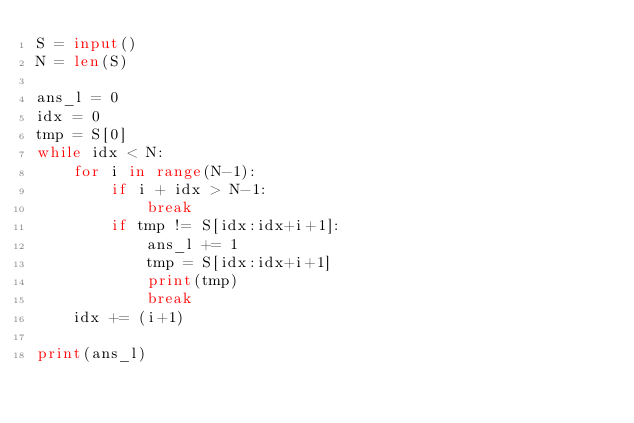<code> <loc_0><loc_0><loc_500><loc_500><_Python_>S = input()
N = len(S)

ans_l = 0
idx = 0
tmp = S[0]
while idx < N:
    for i in range(N-1):
        if i + idx > N-1:
            break
        if tmp != S[idx:idx+i+1]:
            ans_l += 1
            tmp = S[idx:idx+i+1]
            print(tmp)
            break
    idx += (i+1)

print(ans_l)

</code> 